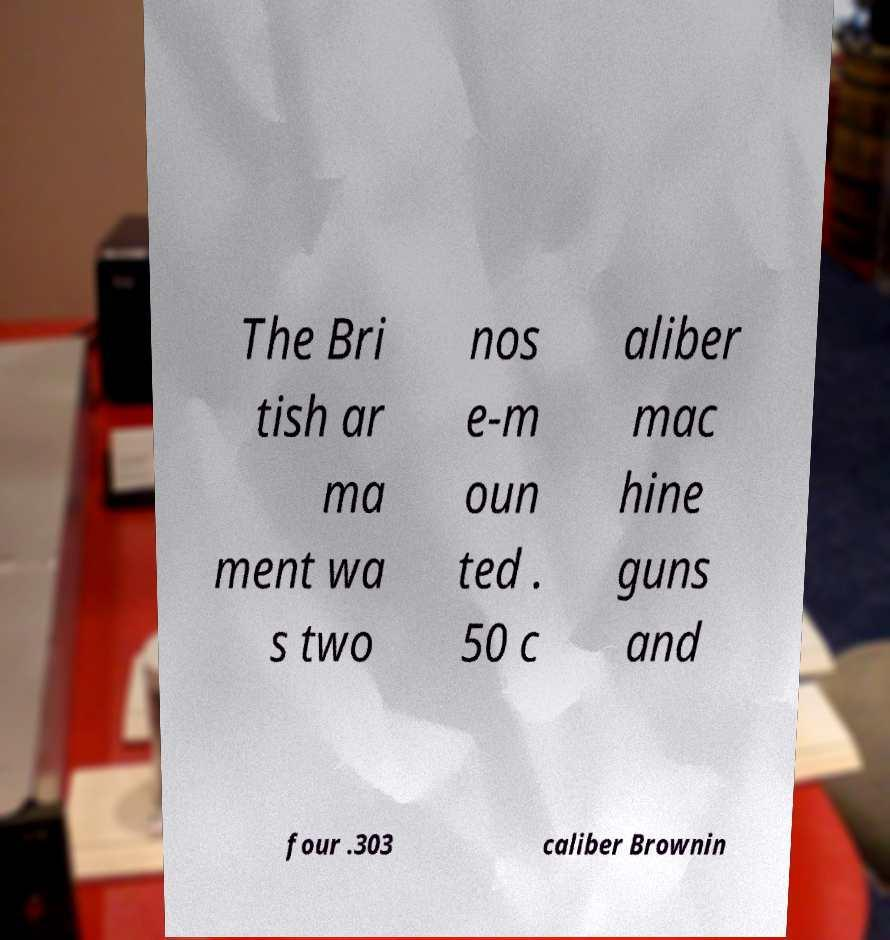Can you read and provide the text displayed in the image?This photo seems to have some interesting text. Can you extract and type it out for me? The Bri tish ar ma ment wa s two nos e-m oun ted . 50 c aliber mac hine guns and four .303 caliber Brownin 